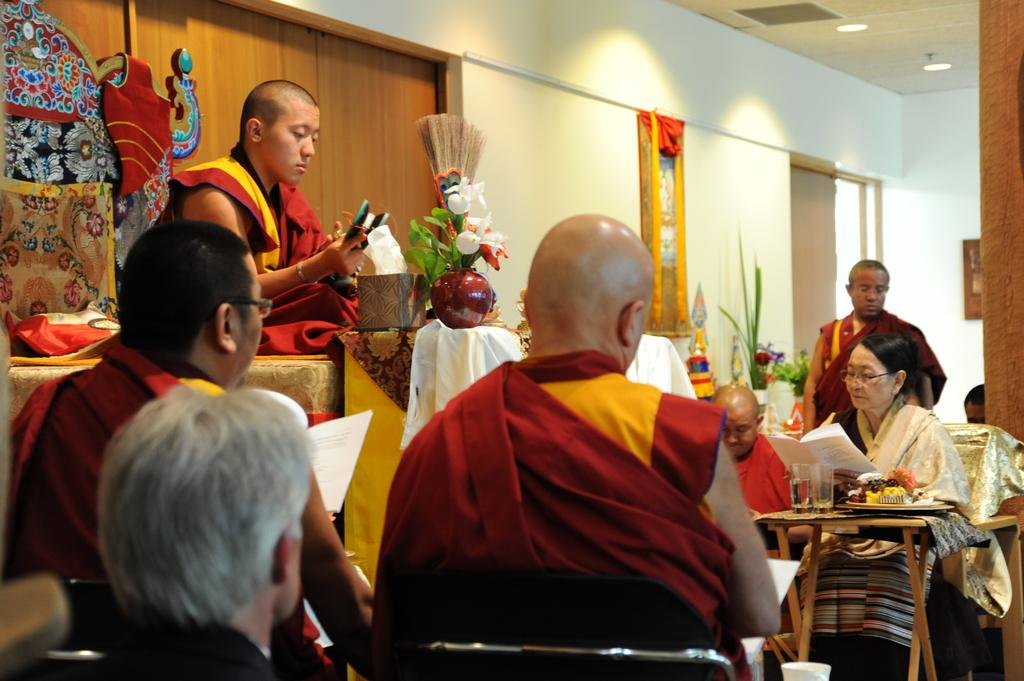What is the color of the wall in the image? The wall in the image is white. What can be used to enter or exit the room in the image? There is a door in the image. What are the people in the image doing? The people in the image are sitting on chairs. What furniture is present in the image? There is a table in the image. What items can be seen on the table? There is a plate and glasses on the table. What type of game is being played on the table in the image? There is no game present on the table in the image; it only has a plate and glasses. How many eyes can be seen on the people sitting in the image? We cannot determine the number of eyes on the people sitting in the image, as their faces are not visible. 